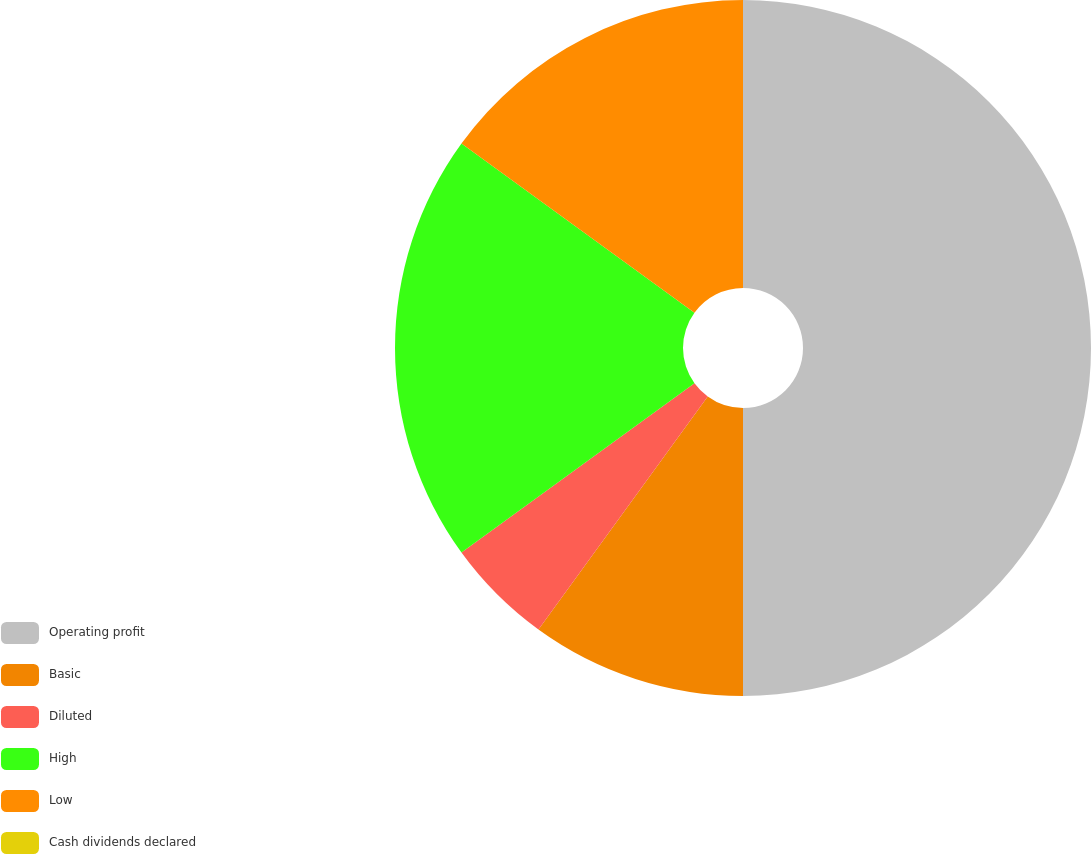<chart> <loc_0><loc_0><loc_500><loc_500><pie_chart><fcel>Operating profit<fcel>Basic<fcel>Diluted<fcel>High<fcel>Low<fcel>Cash dividends declared<nl><fcel>50.0%<fcel>10.0%<fcel>5.0%<fcel>20.0%<fcel>15.0%<fcel>0.0%<nl></chart> 